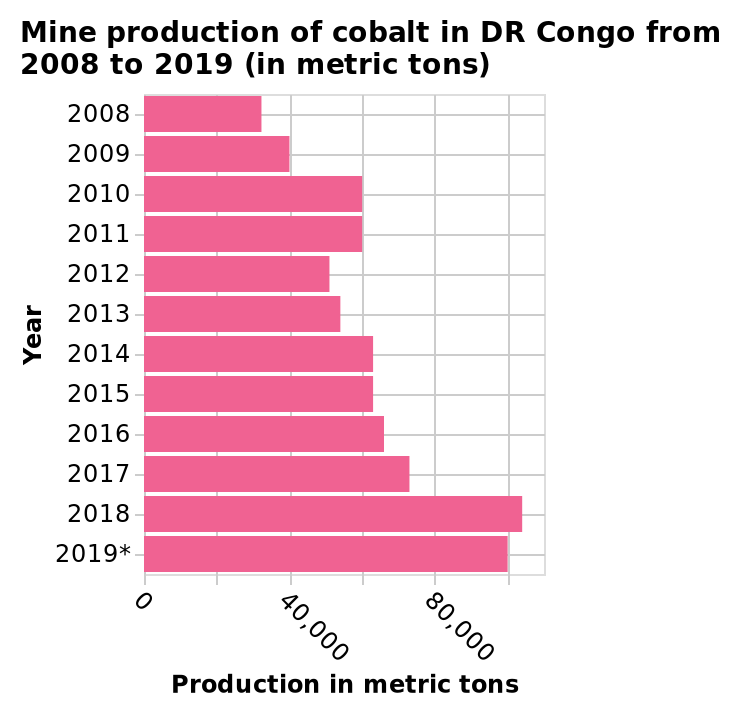<image>
What is the title of the bar diagram? The title of the bar diagram is "Mine production of cobalt in DR Congo from 2008 to 2019 (in metric tons)." please summary the statistics and relations of the chart 2008 shows the lowest amount of cobalt produced at around 30,000 metric tons that year. The highest amount of cobalt produced in one year was in 2018, with a little over 100,000 metric tons. There is a clear upward trend in the amount of cobalt produced year over year. The year 2019 has an asterisk next to it that is at no point defined. 